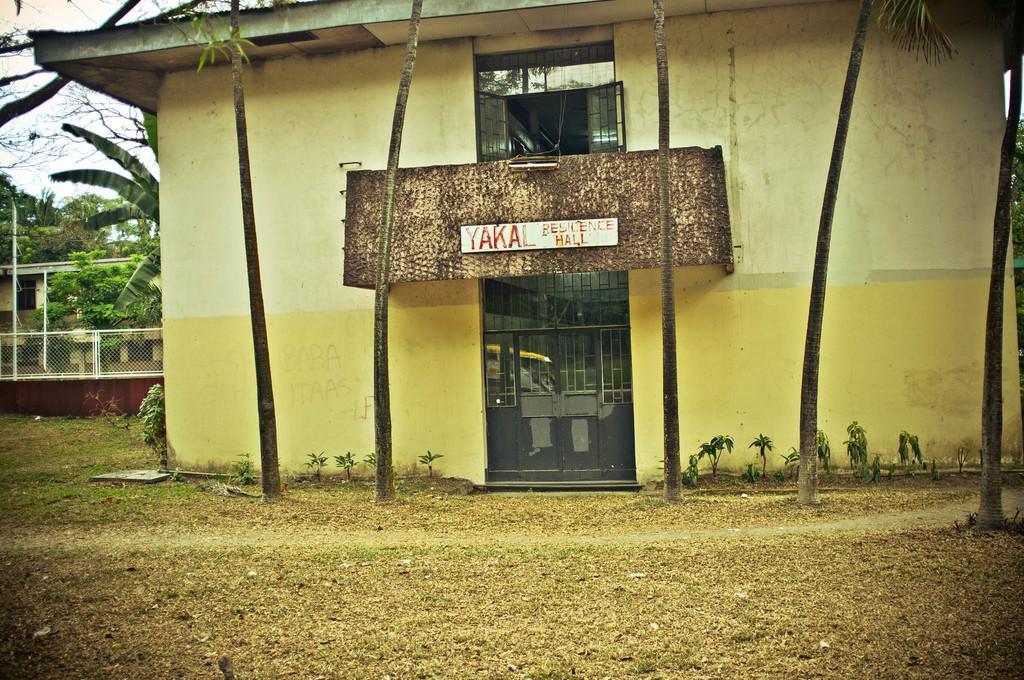Could you give a brief overview of what you see in this image? In this image I can see there is a building and it had a door, there are few trees, there is a fence at the right side and the sky is clear. 